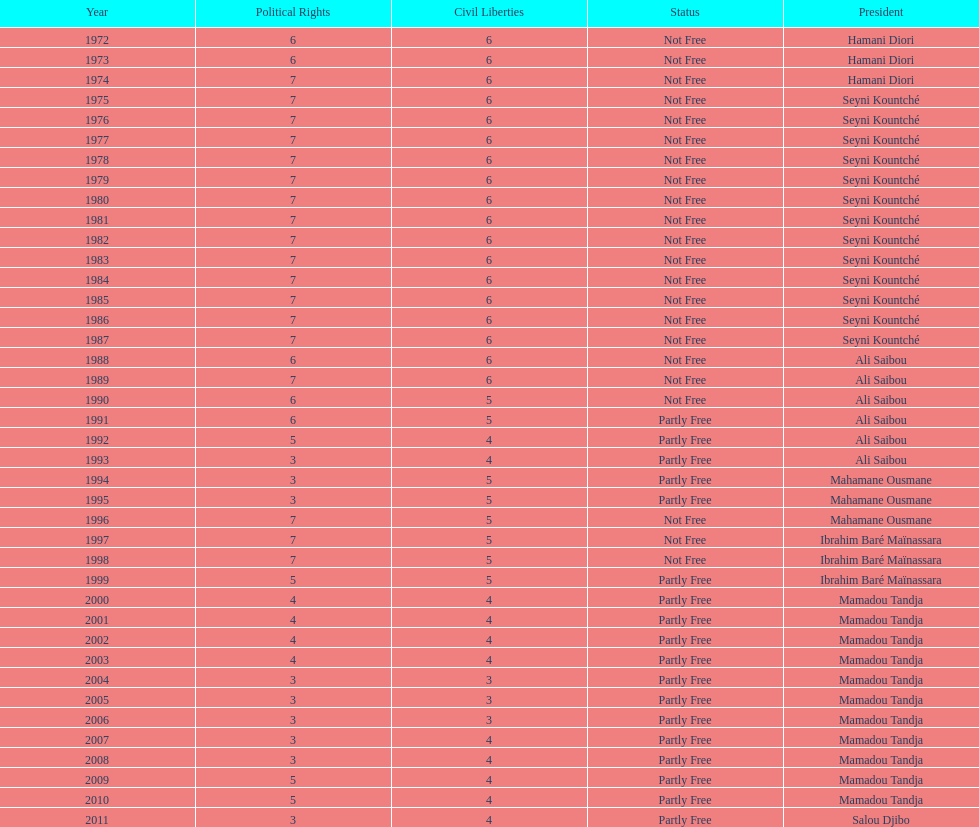What was the duration of ali saibou's presidency? 6. 